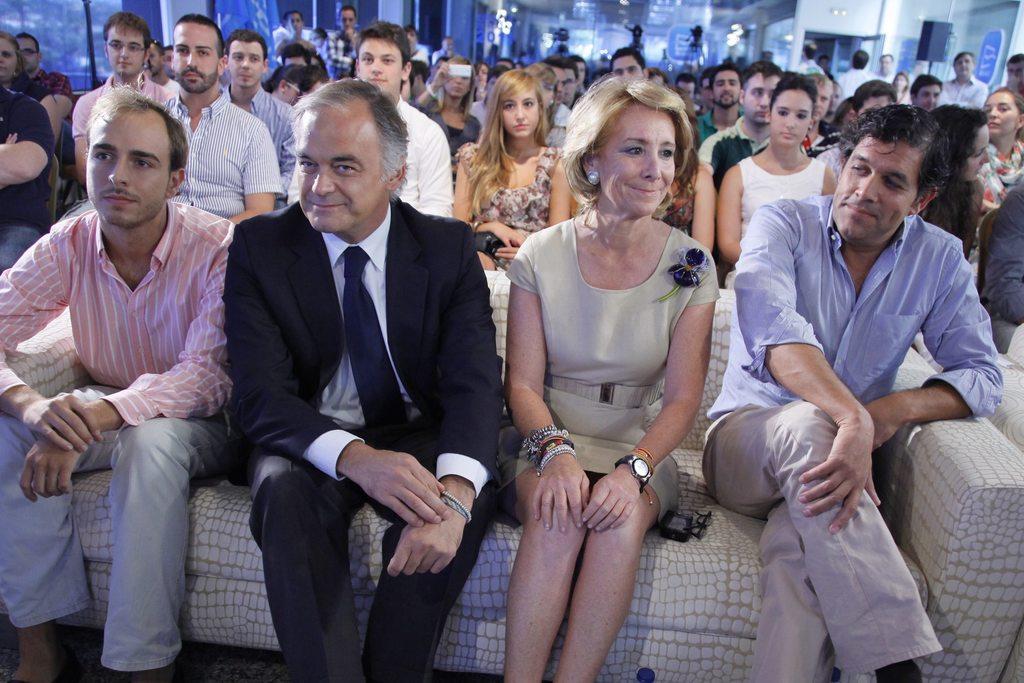How would you summarize this image in a sentence or two? In this picture I can see group of people are sitting. The people in the front of the image are sitting on the sofa. These people are smiling. In the background I can see lights. On the right side I can see wall and black color object. 